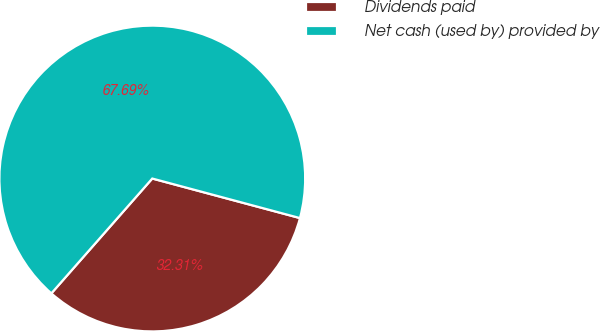Convert chart to OTSL. <chart><loc_0><loc_0><loc_500><loc_500><pie_chart><fcel>Dividends paid<fcel>Net cash (used by) provided by<nl><fcel>32.31%<fcel>67.69%<nl></chart> 